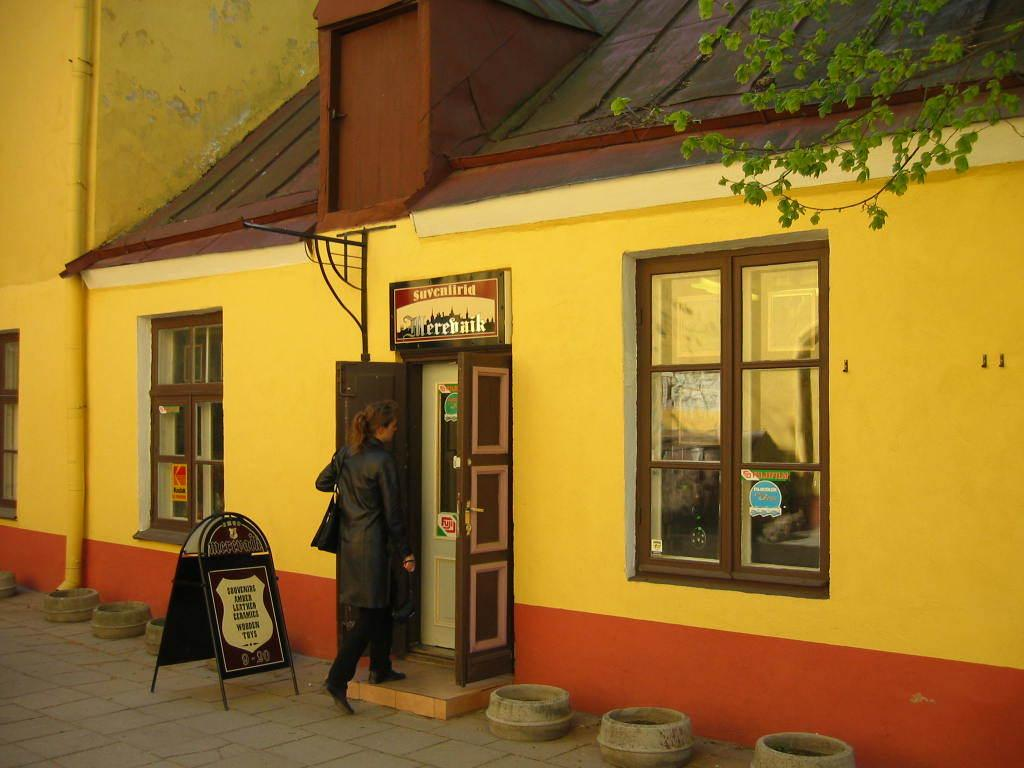Who is the main subject in the image? There is a woman in the image. What is the woman doing in the image? The woman is entering a house. How many windows are visible on the house? The house has two windows on either side. What type of establishment might the house be? The house appears to be a restaurant. What type of vegetation is visible in the image? There is a plant visible on the right side top of the image. What type of bag is the woman carrying in the image? There is no bag visible in the image. How many horses are tied to the restaurant in the image? There are no horses present in the image. 